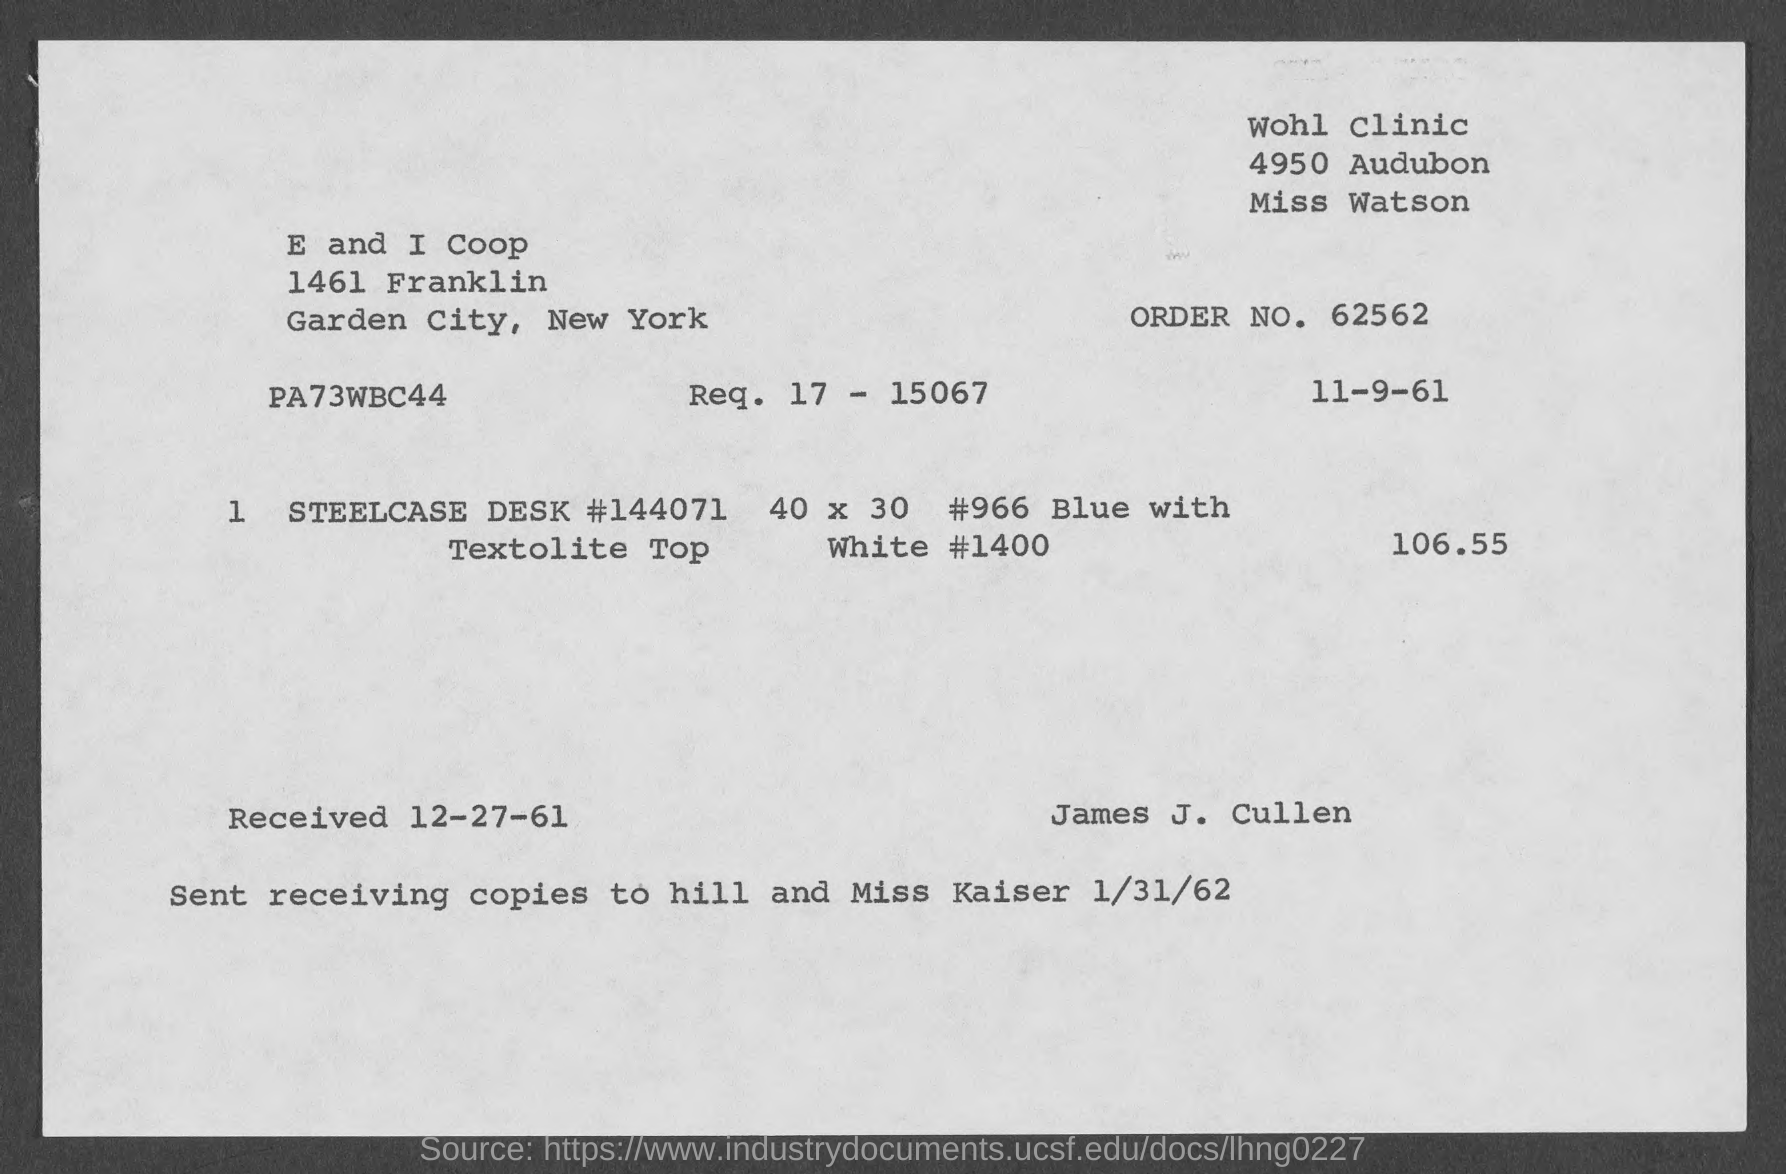Point out several critical features in this image. What is the order number?" the clerk asked. The order number is 62562... The date on the document is November 9th, 1961. I have sent receiving copies to Hill and Miss Kaiser. On December 27, 1961, the item was received. 